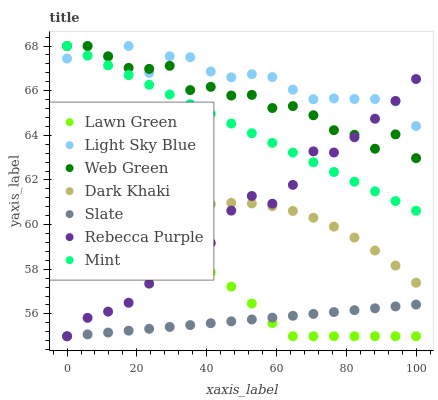Does Slate have the minimum area under the curve?
Answer yes or no. Yes. Does Light Sky Blue have the maximum area under the curve?
Answer yes or no. Yes. Does Web Green have the minimum area under the curve?
Answer yes or no. No. Does Web Green have the maximum area under the curve?
Answer yes or no. No. Is Slate the smoothest?
Answer yes or no. Yes. Is Rebecca Purple the roughest?
Answer yes or no. Yes. Is Web Green the smoothest?
Answer yes or no. No. Is Web Green the roughest?
Answer yes or no. No. Does Lawn Green have the lowest value?
Answer yes or no. Yes. Does Web Green have the lowest value?
Answer yes or no. No. Does Mint have the highest value?
Answer yes or no. Yes. Does Slate have the highest value?
Answer yes or no. No. Is Dark Khaki less than Web Green?
Answer yes or no. Yes. Is Light Sky Blue greater than Slate?
Answer yes or no. Yes. Does Web Green intersect Light Sky Blue?
Answer yes or no. Yes. Is Web Green less than Light Sky Blue?
Answer yes or no. No. Is Web Green greater than Light Sky Blue?
Answer yes or no. No. Does Dark Khaki intersect Web Green?
Answer yes or no. No. 